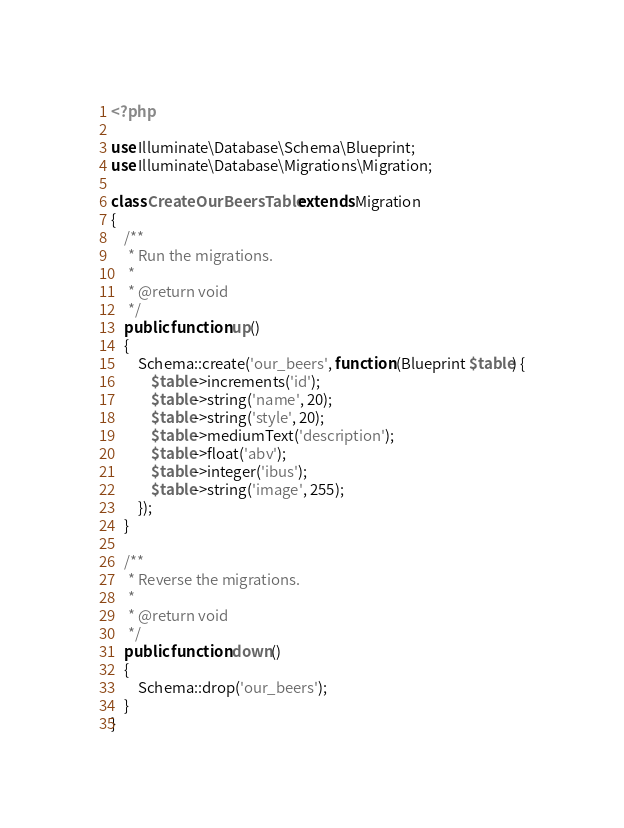Convert code to text. <code><loc_0><loc_0><loc_500><loc_500><_PHP_><?php

use Illuminate\Database\Schema\Blueprint;
use Illuminate\Database\Migrations\Migration;

class CreateOurBeersTable extends Migration
{
    /**
     * Run the migrations.
     *
     * @return void
     */
    public function up()
    {
        Schema::create('our_beers', function (Blueprint $table) {
            $table->increments('id');
            $table->string('name', 20);
            $table->string('style', 20);
            $table->mediumText('description');
            $table->float('abv');
            $table->integer('ibus');
            $table->string('image', 255);
        });
    }

    /**
     * Reverse the migrations.
     *
     * @return void
     */
    public function down()
    {
        Schema::drop('our_beers');
    }
}
</code> 